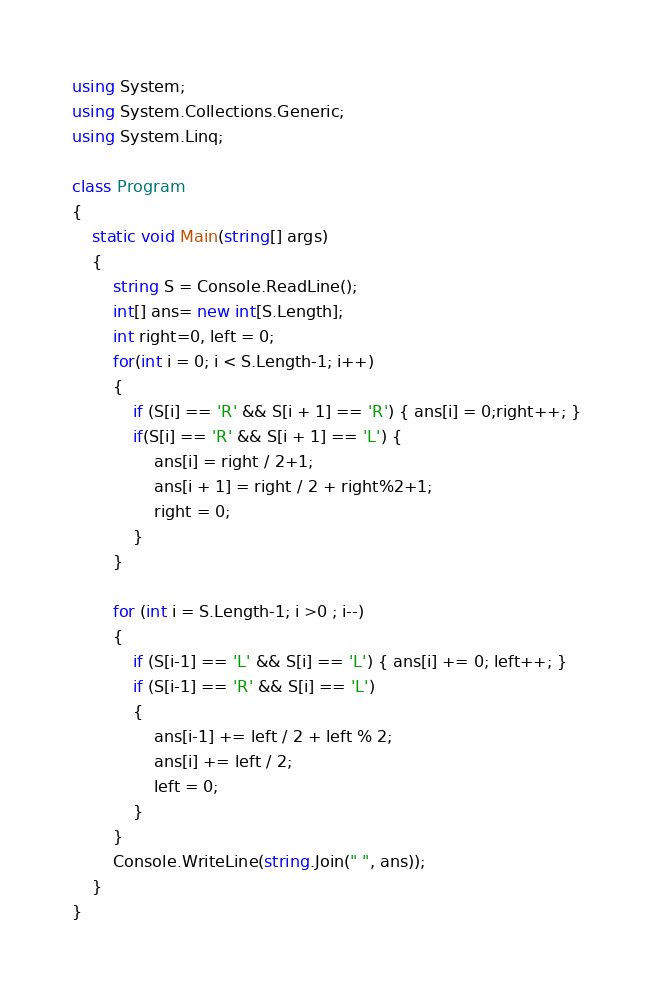<code> <loc_0><loc_0><loc_500><loc_500><_C#_>using System;
using System.Collections.Generic;
using System.Linq;

class Program
{
    static void Main(string[] args)
    {
        string S = Console.ReadLine();
        int[] ans= new int[S.Length];
        int right=0, left = 0;
        for(int i = 0; i < S.Length-1; i++)
        {
            if (S[i] == 'R' && S[i + 1] == 'R') { ans[i] = 0;right++; }
            if(S[i] == 'R' && S[i + 1] == 'L') {
                ans[i] = right / 2+1;
                ans[i + 1] = right / 2 + right%2+1;
                right = 0;
            }
        }

        for (int i = S.Length-1; i >0 ; i--)
        {
            if (S[i-1] == 'L' && S[i] == 'L') { ans[i] += 0; left++; }
            if (S[i-1] == 'R' && S[i] == 'L')
            {
                ans[i-1] += left / 2 + left % 2;
                ans[i] += left / 2;
                left = 0;
            } 
        }
        Console.WriteLine(string.Join(" ", ans));
    }
}
</code> 